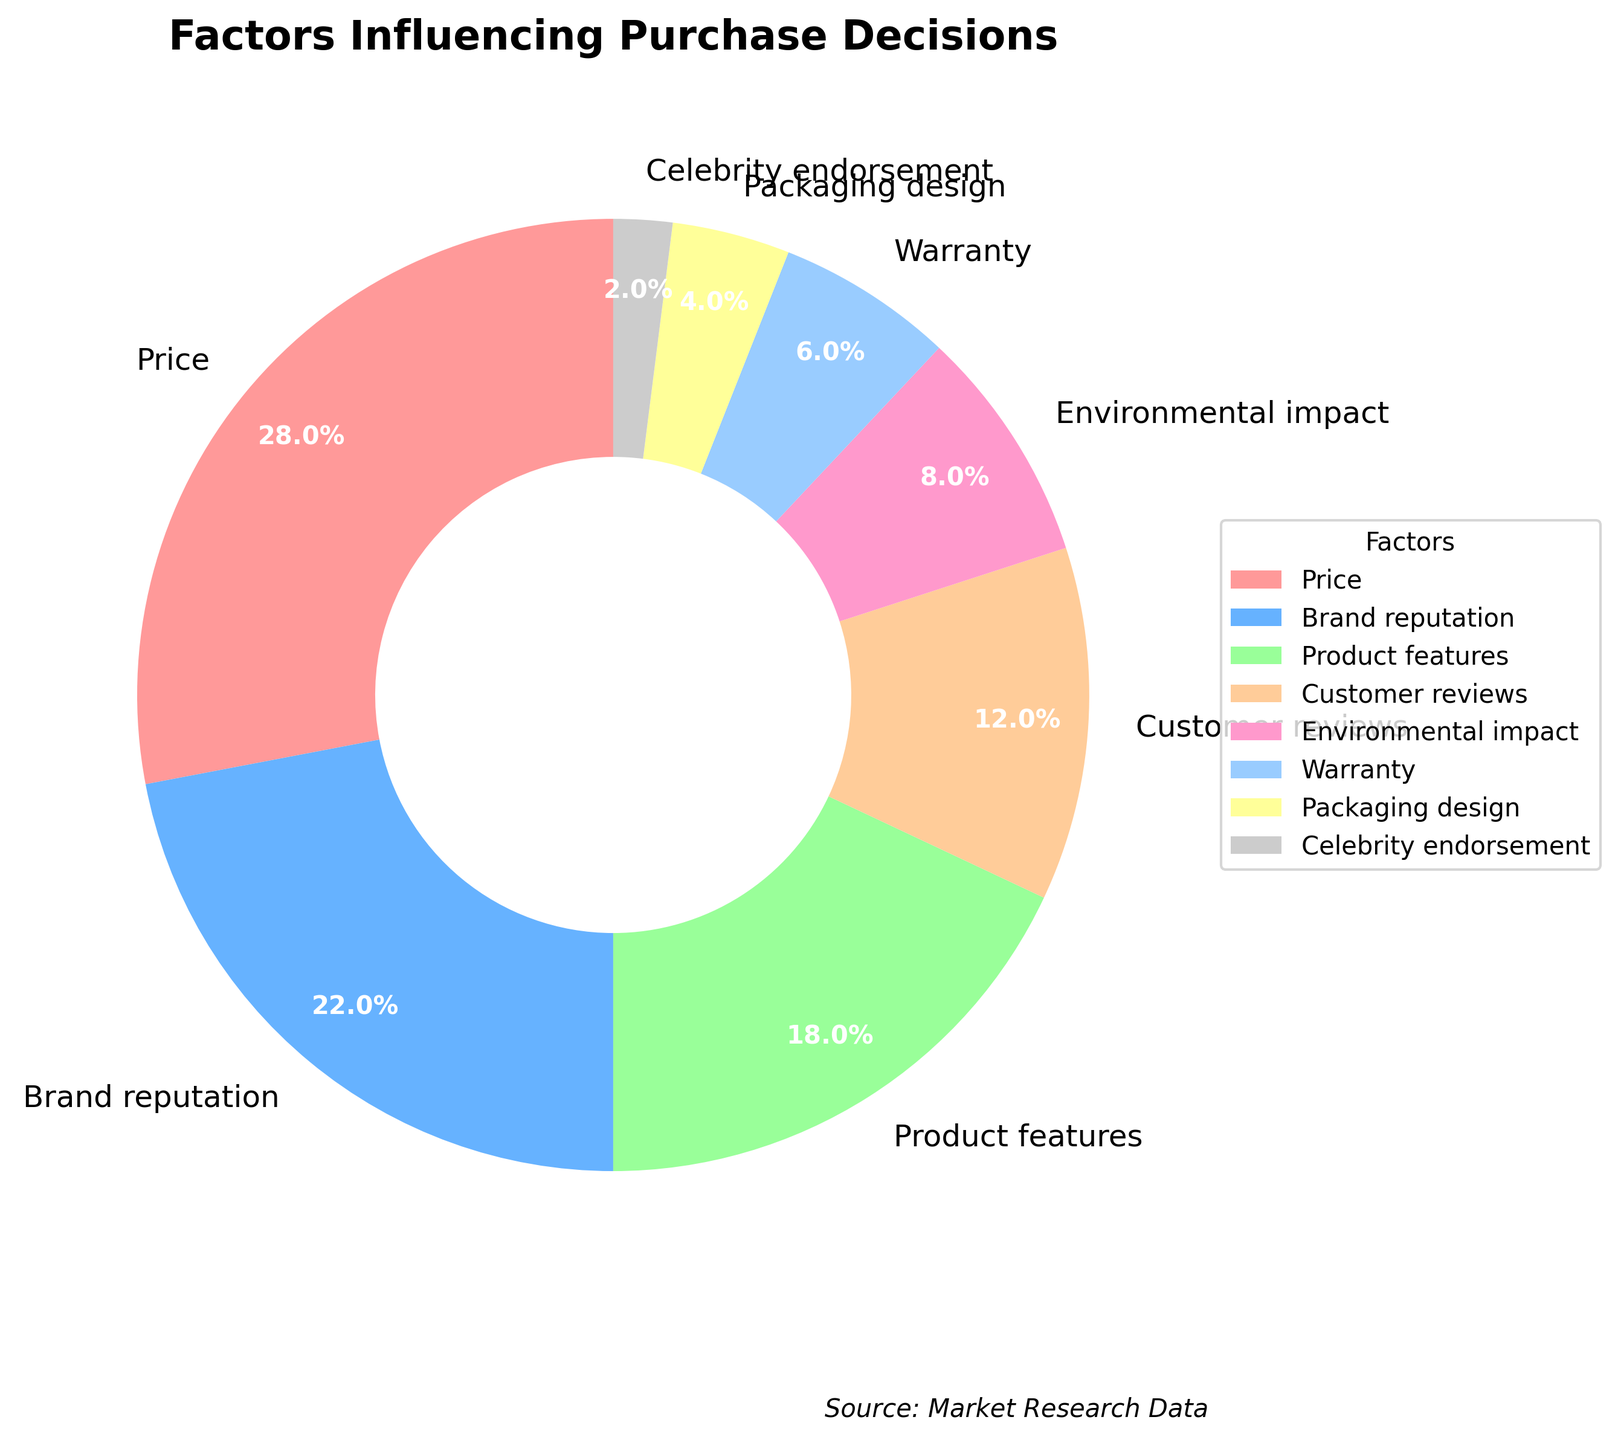Which factor has the highest percentage? The largest slice in the pie chart corresponds to the factor. The "Price" slice is the biggest. Therefore, Price has the highest percentage.
Answer: Price How much more influential is Brand reputation compared to Customer reviews? According to the chart, Brand reputation accounts for 22% and Customer reviews account for 12%. The difference between them is 22% - 12% = 10%.
Answer: 10% How many factors have an influence greater than 10%? From the chart, factors with percentages greater than 10% are Price (28%), Brand reputation (22%), and Product features (18%). Counting these gives us three factors.
Answer: 3 What's the combined percentage of the factors Warranty and Environmental impact? According to the chart, Warranty has 6% and Environmental impact has 8%. The sum of these percentages is 6% + 8% = 14%.
Answer: 14% Which is the least influential factor? The smallest slice in the pie chart indicates the least influential factor. The smallest slice corresponds to Celebrity endorsement with 2%.
Answer: Celebrity endorsement Are the combined influences of Packaging design and Celebrity endorsement more than Product features? Packaging design has 4% and Celebrity endorsement has 2%, totaling 4% + 2% = 6%. Product features have 18%. 6% is not greater than 18%.
Answer: No What is the combined percentage of customer reviews and packaging design? Customer reviews account for 12% and packaging design accounts for 4%. Adding these percentages gives us 12% + 4% = 16%.
Answer: 16% How does the influence of environmental impact compare to that of warranty? Environmental impact accounts for 8% while warranty accounts for 6%. The difference is 8% - 6% = 2%, which means environmental impact has a slightly greater influence than warranty.
Answer: 2% Which factors collectively make up less than half of the pie chart? Considering the percentages of all factors, the sum of smaller factors must be less than 50%. Adding percentages: Warranty (6%) + Packaging design (4%) + Celebrity endorsement (2%) = 12% + Environmental impact (8%) = 20% + Customer reviews (12%) = 32%. These five factors make up less than half of the chart.
Answer: Warranty, Packaging design, Celebrity endorsement, Environmental impact, Customer reviews What percentage of influence does Product features have in relation to the total pie chart? Product features account for 18%. Since the entire chart represents 100%, the 18% portion represents that amount of influence.
Answer: 18% 